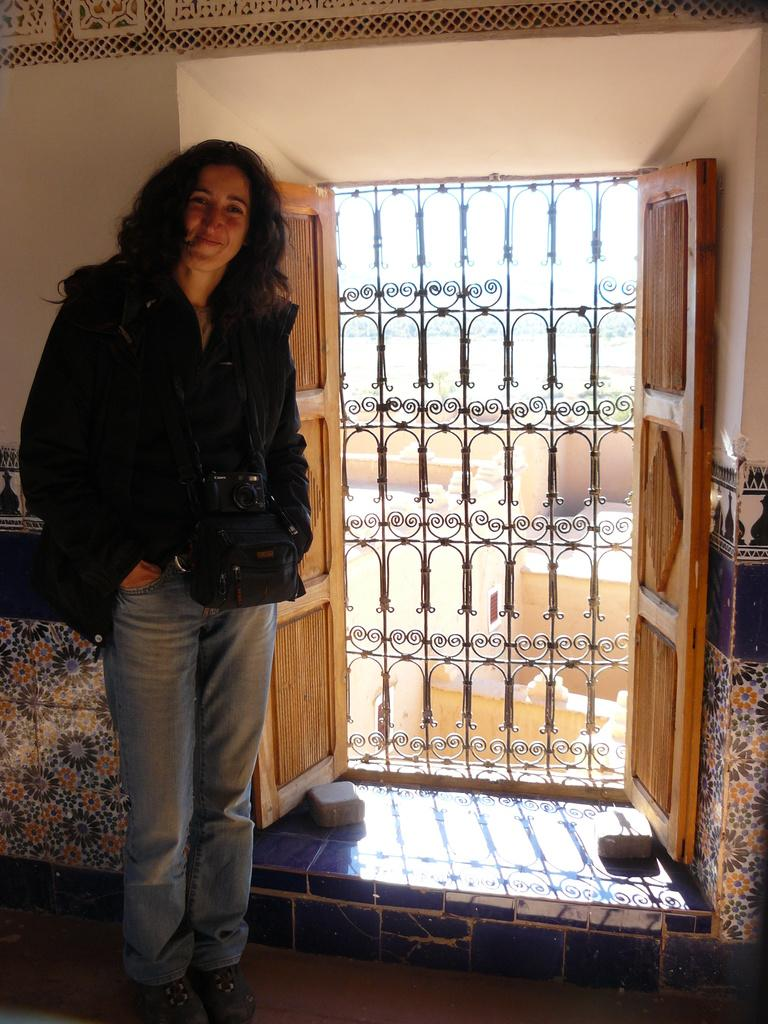Who is present in the image? There is a woman in the image. What is the woman wearing? The woman is wearing a camera. What is the woman doing in the image? The woman is standing and smiling. What can be seen in the background of the image? There are doors, a door grill, and a wall in the background of the image. What type of cork can be seen on the table in the image? There is no table or cork present in the image. How old is the woman's son in the image? There is no son present in the image, so it is not possible to determine his age. 